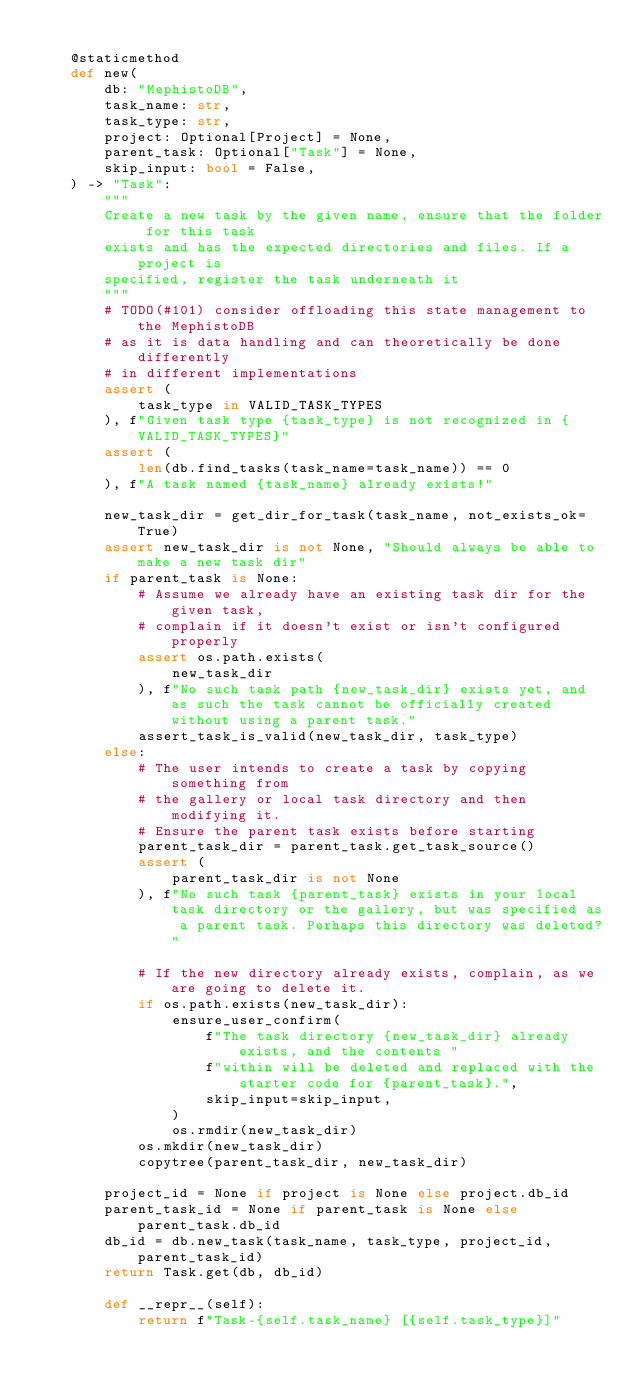Convert code to text. <code><loc_0><loc_0><loc_500><loc_500><_Python_>
    @staticmethod
    def new(
        db: "MephistoDB",
        task_name: str,
        task_type: str,
        project: Optional[Project] = None,
        parent_task: Optional["Task"] = None,
        skip_input: bool = False,
    ) -> "Task":
        """
        Create a new task by the given name, ensure that the folder for this task
        exists and has the expected directories and files. If a project is
        specified, register the task underneath it
        """
        # TODO(#101) consider offloading this state management to the MephistoDB
        # as it is data handling and can theoretically be done differently
        # in different implementations
        assert (
            task_type in VALID_TASK_TYPES
        ), f"Given task type {task_type} is not recognized in {VALID_TASK_TYPES}"
        assert (
            len(db.find_tasks(task_name=task_name)) == 0
        ), f"A task named {task_name} already exists!"

        new_task_dir = get_dir_for_task(task_name, not_exists_ok=True)
        assert new_task_dir is not None, "Should always be able to make a new task dir"
        if parent_task is None:
            # Assume we already have an existing task dir for the given task,
            # complain if it doesn't exist or isn't configured properly
            assert os.path.exists(
                new_task_dir
            ), f"No such task path {new_task_dir} exists yet, and as such the task cannot be officially created without using a parent task."
            assert_task_is_valid(new_task_dir, task_type)
        else:
            # The user intends to create a task by copying something from
            # the gallery or local task directory and then modifying it.
            # Ensure the parent task exists before starting
            parent_task_dir = parent_task.get_task_source()
            assert (
                parent_task_dir is not None
            ), f"No such task {parent_task} exists in your local task directory or the gallery, but was specified as a parent task. Perhaps this directory was deleted?"

            # If the new directory already exists, complain, as we are going to delete it.
            if os.path.exists(new_task_dir):
                ensure_user_confirm(
                    f"The task directory {new_task_dir} already exists, and the contents "
                    f"within will be deleted and replaced with the starter code for {parent_task}.",
                    skip_input=skip_input,
                )
                os.rmdir(new_task_dir)
            os.mkdir(new_task_dir)
            copytree(parent_task_dir, new_task_dir)

        project_id = None if project is None else project.db_id
        parent_task_id = None if parent_task is None else parent_task.db_id
        db_id = db.new_task(task_name, task_type, project_id, parent_task_id)
        return Task.get(db, db_id)

        def __repr__(self):
            return f"Task-{self.task_name} [{self.task_type}]"
</code> 